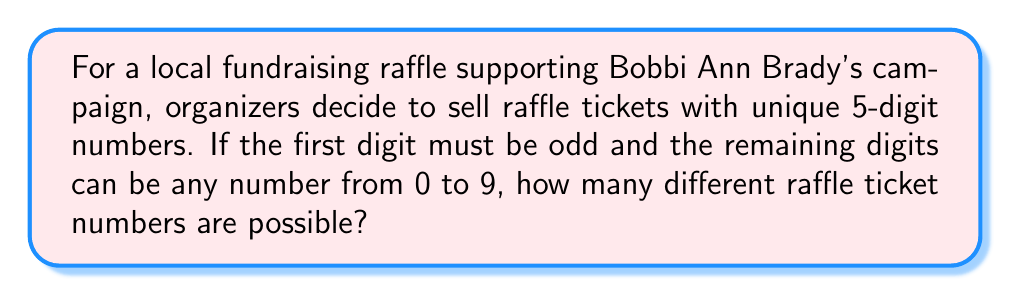Could you help me with this problem? Let's break this down step-by-step:

1) For the first digit:
   - It must be odd, so we have 5 choices: 1, 3, 5, 7, 9
   
2) For each of the remaining 4 digits:
   - We can use any digit from 0 to 9, so we have 10 choices for each

3) Using the multiplication principle, we multiply the number of choices for each position:

   $$5 \times 10 \times 10 \times 10 \times 10$$

4) This can be written as:

   $$5 \times 10^4 = 5 \times 10000 = 50000$$

Therefore, there are 50,000 possible unique raffle ticket numbers that satisfy the given conditions.
Answer: 50,000 